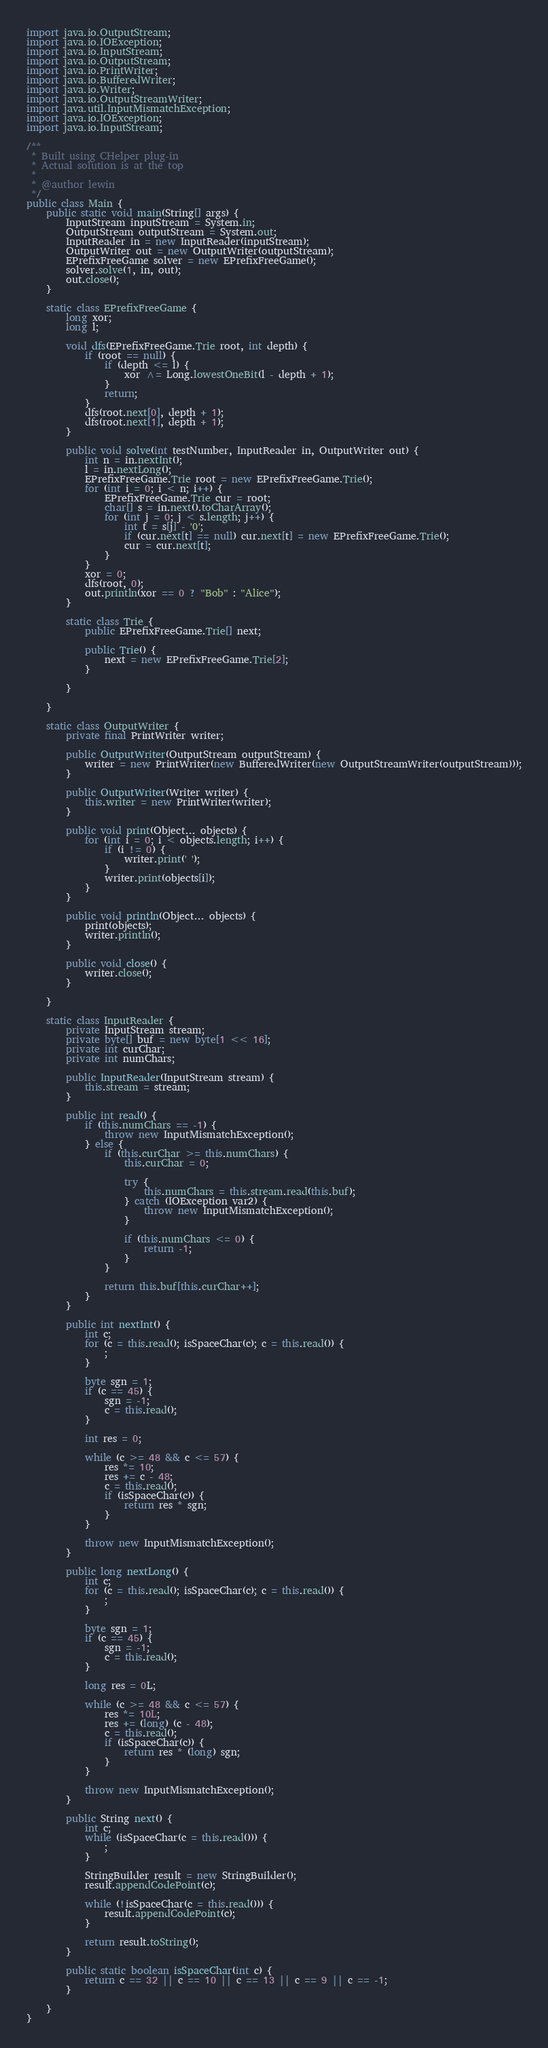Convert code to text. <code><loc_0><loc_0><loc_500><loc_500><_Java_>import java.io.OutputStream;
import java.io.IOException;
import java.io.InputStream;
import java.io.OutputStream;
import java.io.PrintWriter;
import java.io.BufferedWriter;
import java.io.Writer;
import java.io.OutputStreamWriter;
import java.util.InputMismatchException;
import java.io.IOException;
import java.io.InputStream;

/**
 * Built using CHelper plug-in
 * Actual solution is at the top
 *
 * @author lewin
 */
public class Main {
    public static void main(String[] args) {
        InputStream inputStream = System.in;
        OutputStream outputStream = System.out;
        InputReader in = new InputReader(inputStream);
        OutputWriter out = new OutputWriter(outputStream);
        EPrefixFreeGame solver = new EPrefixFreeGame();
        solver.solve(1, in, out);
        out.close();
    }

    static class EPrefixFreeGame {
        long xor;
        long l;

        void dfs(EPrefixFreeGame.Trie root, int depth) {
            if (root == null) {
                if (depth <= l) {
                    xor ^= Long.lowestOneBit(l - depth + 1);
                }
                return;
            }
            dfs(root.next[0], depth + 1);
            dfs(root.next[1], depth + 1);
        }

        public void solve(int testNumber, InputReader in, OutputWriter out) {
            int n = in.nextInt();
            l = in.nextLong();
            EPrefixFreeGame.Trie root = new EPrefixFreeGame.Trie();
            for (int i = 0; i < n; i++) {
                EPrefixFreeGame.Trie cur = root;
                char[] s = in.next().toCharArray();
                for (int j = 0; j < s.length; j++) {
                    int t = s[j] - '0';
                    if (cur.next[t] == null) cur.next[t] = new EPrefixFreeGame.Trie();
                    cur = cur.next[t];
                }
            }
            xor = 0;
            dfs(root, 0);
            out.println(xor == 0 ? "Bob" : "Alice");
        }

        static class Trie {
            public EPrefixFreeGame.Trie[] next;

            public Trie() {
                next = new EPrefixFreeGame.Trie[2];
            }

        }

    }

    static class OutputWriter {
        private final PrintWriter writer;

        public OutputWriter(OutputStream outputStream) {
            writer = new PrintWriter(new BufferedWriter(new OutputStreamWriter(outputStream)));
        }

        public OutputWriter(Writer writer) {
            this.writer = new PrintWriter(writer);
        }

        public void print(Object... objects) {
            for (int i = 0; i < objects.length; i++) {
                if (i != 0) {
                    writer.print(' ');
                }
                writer.print(objects[i]);
            }
        }

        public void println(Object... objects) {
            print(objects);
            writer.println();
        }

        public void close() {
            writer.close();
        }

    }

    static class InputReader {
        private InputStream stream;
        private byte[] buf = new byte[1 << 16];
        private int curChar;
        private int numChars;

        public InputReader(InputStream stream) {
            this.stream = stream;
        }

        public int read() {
            if (this.numChars == -1) {
                throw new InputMismatchException();
            } else {
                if (this.curChar >= this.numChars) {
                    this.curChar = 0;

                    try {
                        this.numChars = this.stream.read(this.buf);
                    } catch (IOException var2) {
                        throw new InputMismatchException();
                    }

                    if (this.numChars <= 0) {
                        return -1;
                    }
                }

                return this.buf[this.curChar++];
            }
        }

        public int nextInt() {
            int c;
            for (c = this.read(); isSpaceChar(c); c = this.read()) {
                ;
            }

            byte sgn = 1;
            if (c == 45) {
                sgn = -1;
                c = this.read();
            }

            int res = 0;

            while (c >= 48 && c <= 57) {
                res *= 10;
                res += c - 48;
                c = this.read();
                if (isSpaceChar(c)) {
                    return res * sgn;
                }
            }

            throw new InputMismatchException();
        }

        public long nextLong() {
            int c;
            for (c = this.read(); isSpaceChar(c); c = this.read()) {
                ;
            }

            byte sgn = 1;
            if (c == 45) {
                sgn = -1;
                c = this.read();
            }

            long res = 0L;

            while (c >= 48 && c <= 57) {
                res *= 10L;
                res += (long) (c - 48);
                c = this.read();
                if (isSpaceChar(c)) {
                    return res * (long) sgn;
                }
            }

            throw new InputMismatchException();
        }

        public String next() {
            int c;
            while (isSpaceChar(c = this.read())) {
                ;
            }

            StringBuilder result = new StringBuilder();
            result.appendCodePoint(c);

            while (!isSpaceChar(c = this.read())) {
                result.appendCodePoint(c);
            }

            return result.toString();
        }

        public static boolean isSpaceChar(int c) {
            return c == 32 || c == 10 || c == 13 || c == 9 || c == -1;
        }

    }
}

</code> 